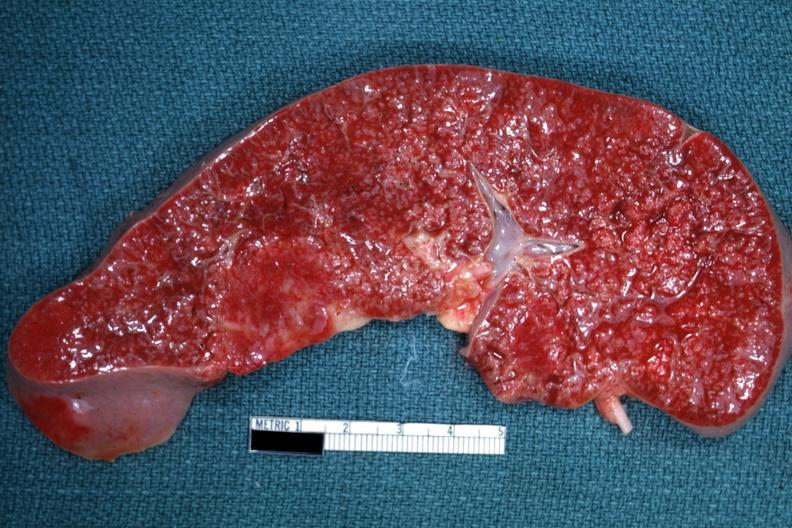s malignant lymphoma present?
Answer the question using a single word or phrase. Yes 